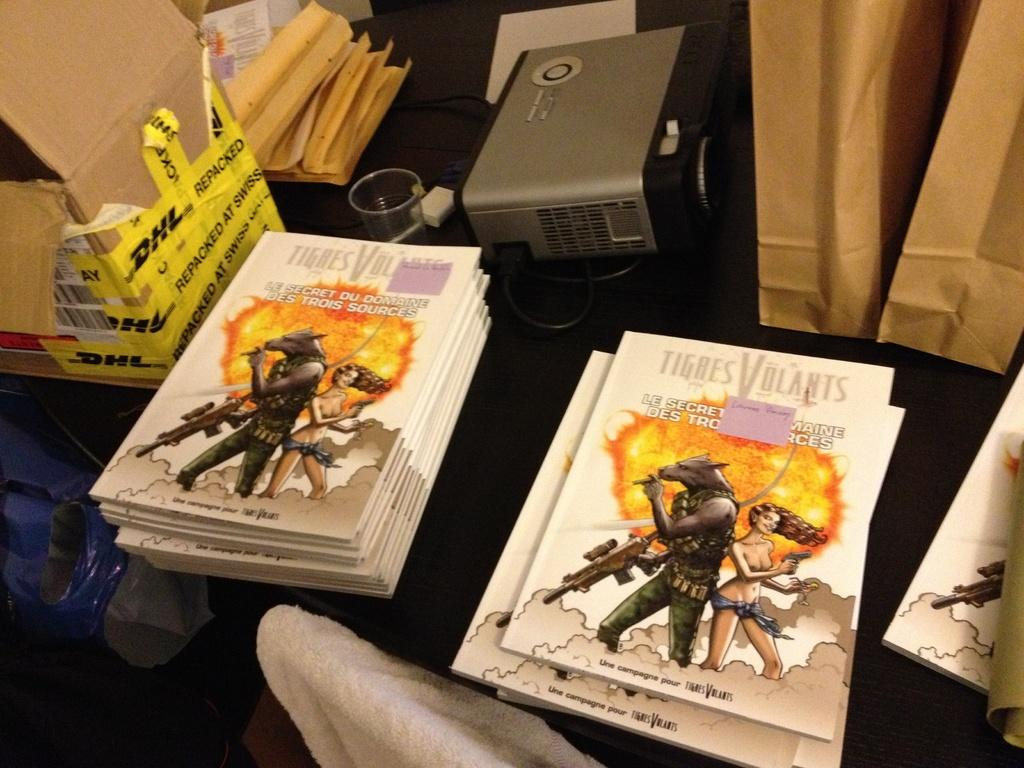<image>
Summarize the visual content of the image. Several copies of Tigres Volants stacked in two piles on a table 